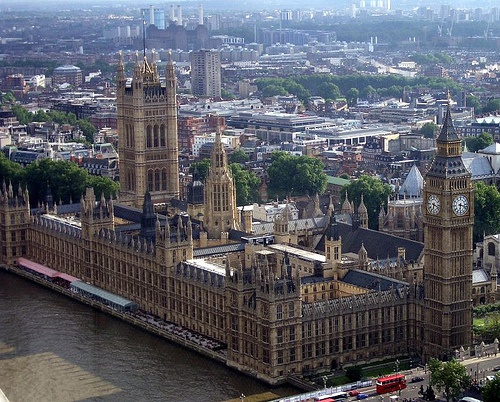Describe the objects in this image and their specific colors. I can see bus in lavender, maroon, black, brown, and salmon tones, bus in lavender, black, white, gray, and darkgray tones, clock in lavender, darkgray, gray, lightgray, and black tones, clock in lavender, gray, darkgray, black, and lightgray tones, and car in lavender, navy, black, darkgray, and darkblue tones in this image. 